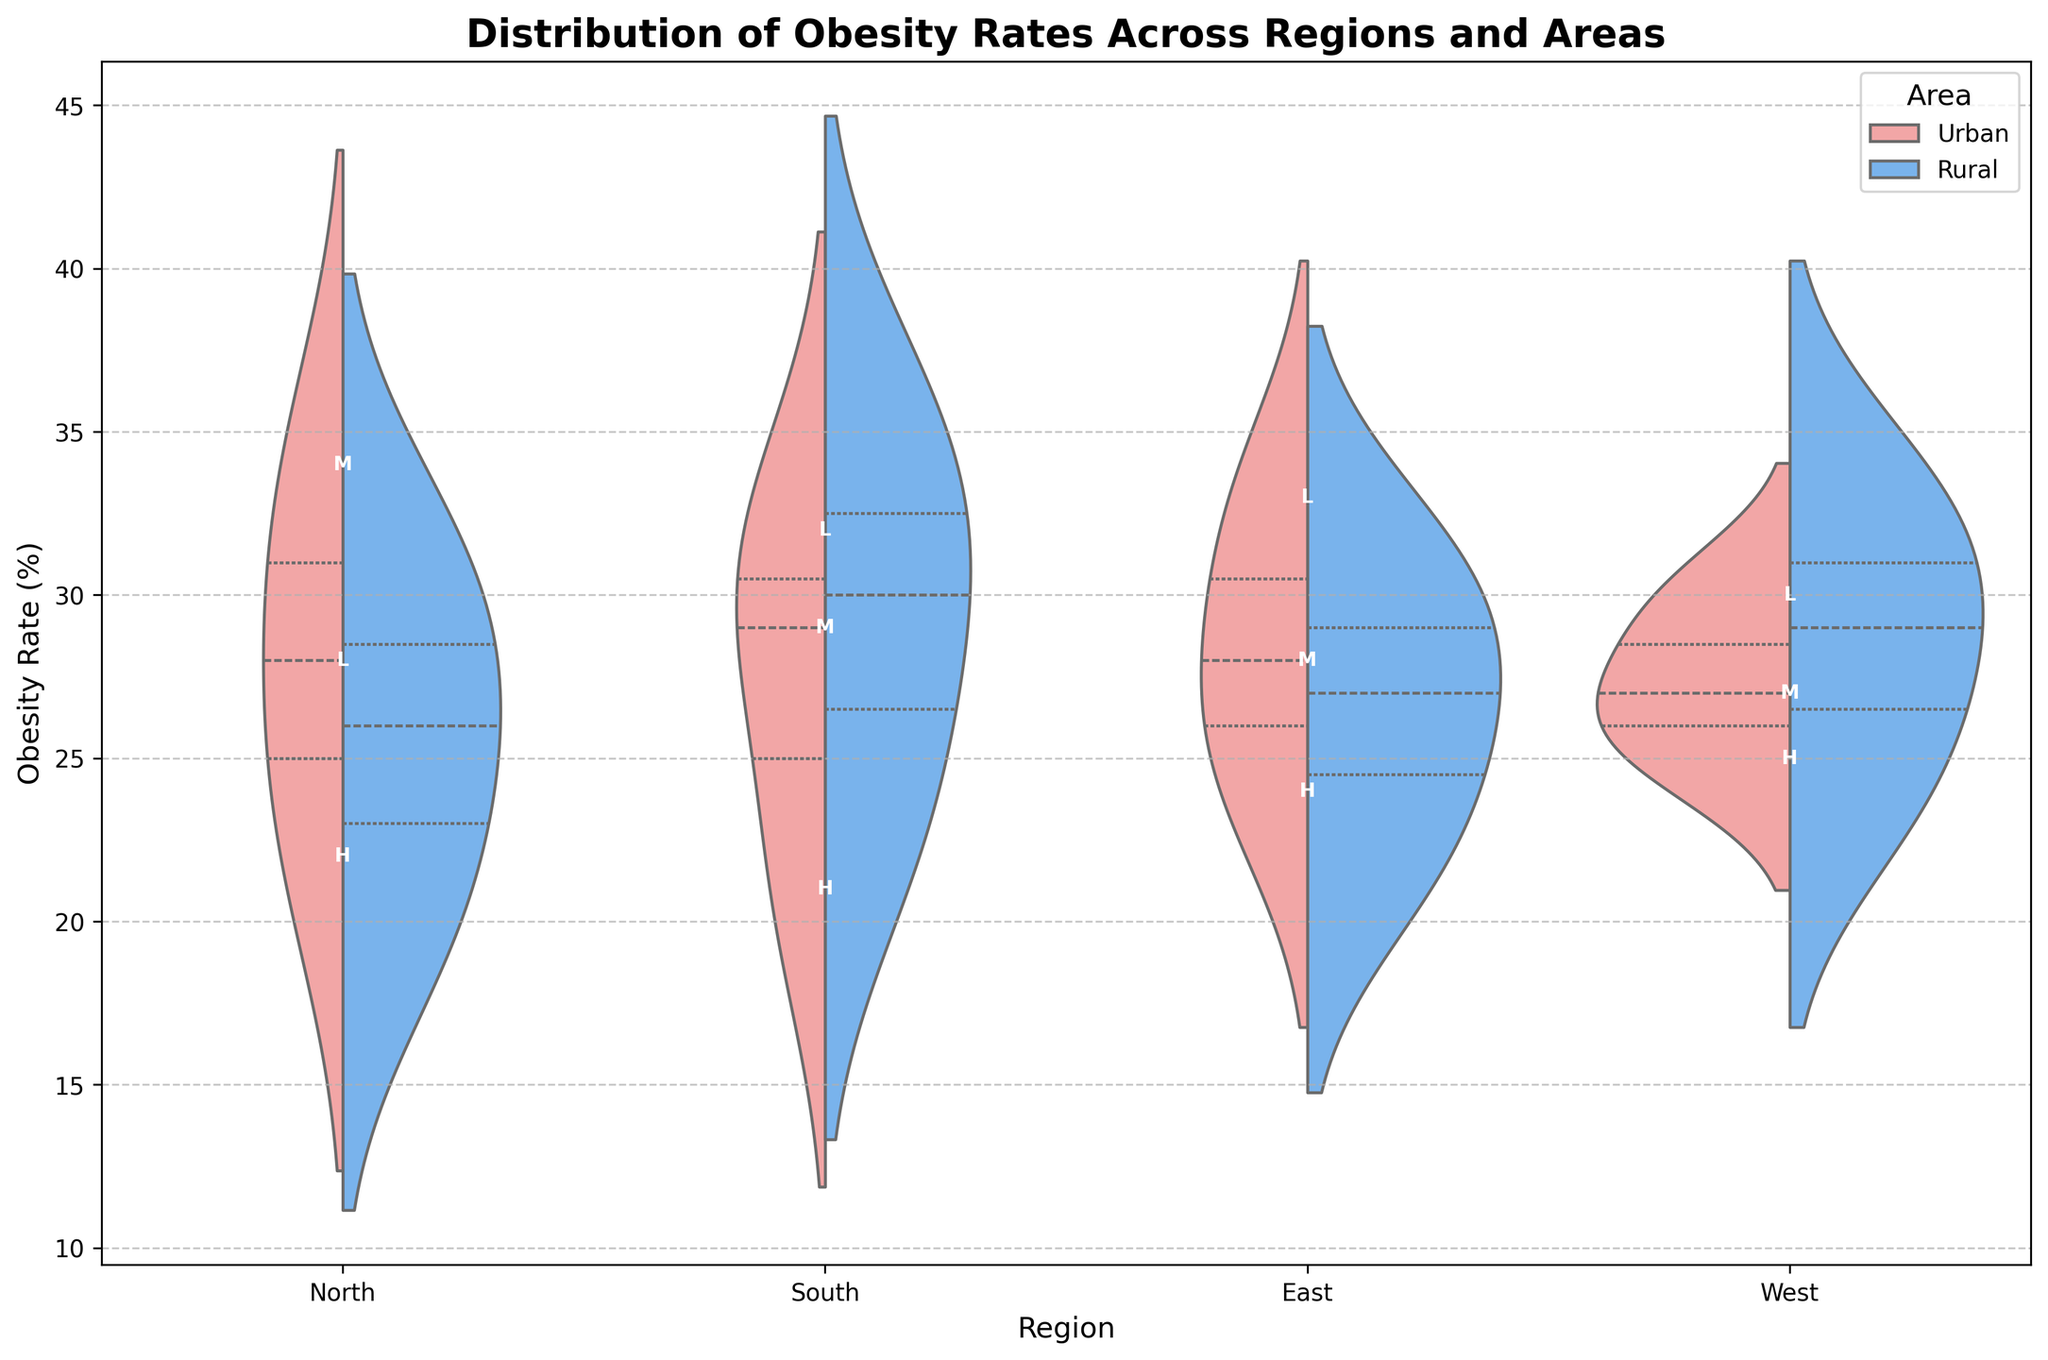What is the title of the plot? The title of a plot is usually centered at the top and is in a larger, bold font size. In this case, the title is "Distribution of Obesity Rates Across Regions and Areas," which can be directly read from the plot.
Answer: Distribution of Obesity Rates Across Regions and Areas What are the two areas compared in the plot? The legend to the right of the plot indicates the compared areas by color: "Urban" in the reddish color and "Rural" in blue.
Answer: Urban and Rural Which region seems to have the highest median obesity rate for urban areas? To determine the median obesity rate for urban areas in different regions, look at the central white lines within the reddish violin shapes. The North region appears to have the highest median as its central line is at a higher obesity rate compared to others.
Answer: North How does the obesity rate distribution for low-income groups compare between the East and West regions? For comparison, look at the distribution shapes (violins) for the low-income group in both the East and West regions. The East region shows a slightly higher and tighter obesity rate distribution, while the West shows a wider spread.
Answer: East has a higher and tighter distribution than West What is the general trend seen when comparing urban and rural obesity rates across the different regions? Observing the split violins for each region, the urban areas generally have violin shapes with lower obesity rate medians compared to rural areas. This suggests a higher obesity rate trend in rural areas across all regions.
Answer: Rural areas have higher obesity rates Are there any regions where urban and rural obesity rates are almost equal? To check for equality, compare the central lines of the urban and rural violins within each region. The West region shows that the obesity rates for urban and rural areas are almost equal as the central lines are very close in value.
Answer: West Which income group is denoted by the letter "M" in the plot, and what does this imply about its obesity rates? The letter "M" in the annotations indicates the "Middle" income group. By looking at where this letter appears in each region, it shows the obesity rates for middle-income groups. These rates tend to be between the high and low-income groups.
Answer: Middle, moderate obesity rates Is the distribution of obesity rates more variable in urban or rural areas in the South region? To determine the variability, analyze the width and spread of the violins for urban (reddish) and rural (blue) areas in the South region. The rural area's violin is wider and has a greater spread, indicating more variability.
Answer: Rural What color represents the urban areas in the plot? The legend or the color of the more reddish violins represents the urban areas, showing a distinction from the blue rural areas.
Answer: Reddish color Which region exhibits the lowest median obesity rate for high-income groups in rural areas? To find the lowest median, look at the central white lines within the blue violins for high-income groups across regions. The North region has the lowest median for rural high-income groups as its central line is the lowest.
Answer: North 